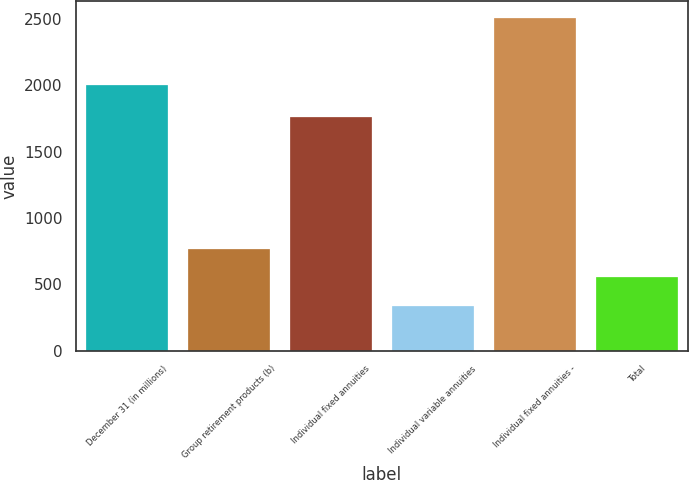<chart> <loc_0><loc_0><loc_500><loc_500><bar_chart><fcel>December 31 (in millions)<fcel>Group retirement products (b)<fcel>Individual fixed annuities<fcel>Individual variable annuities<fcel>Individual fixed annuities -<fcel>Total<nl><fcel>2005<fcel>770.4<fcel>1759<fcel>336<fcel>2508<fcel>553.2<nl></chart> 